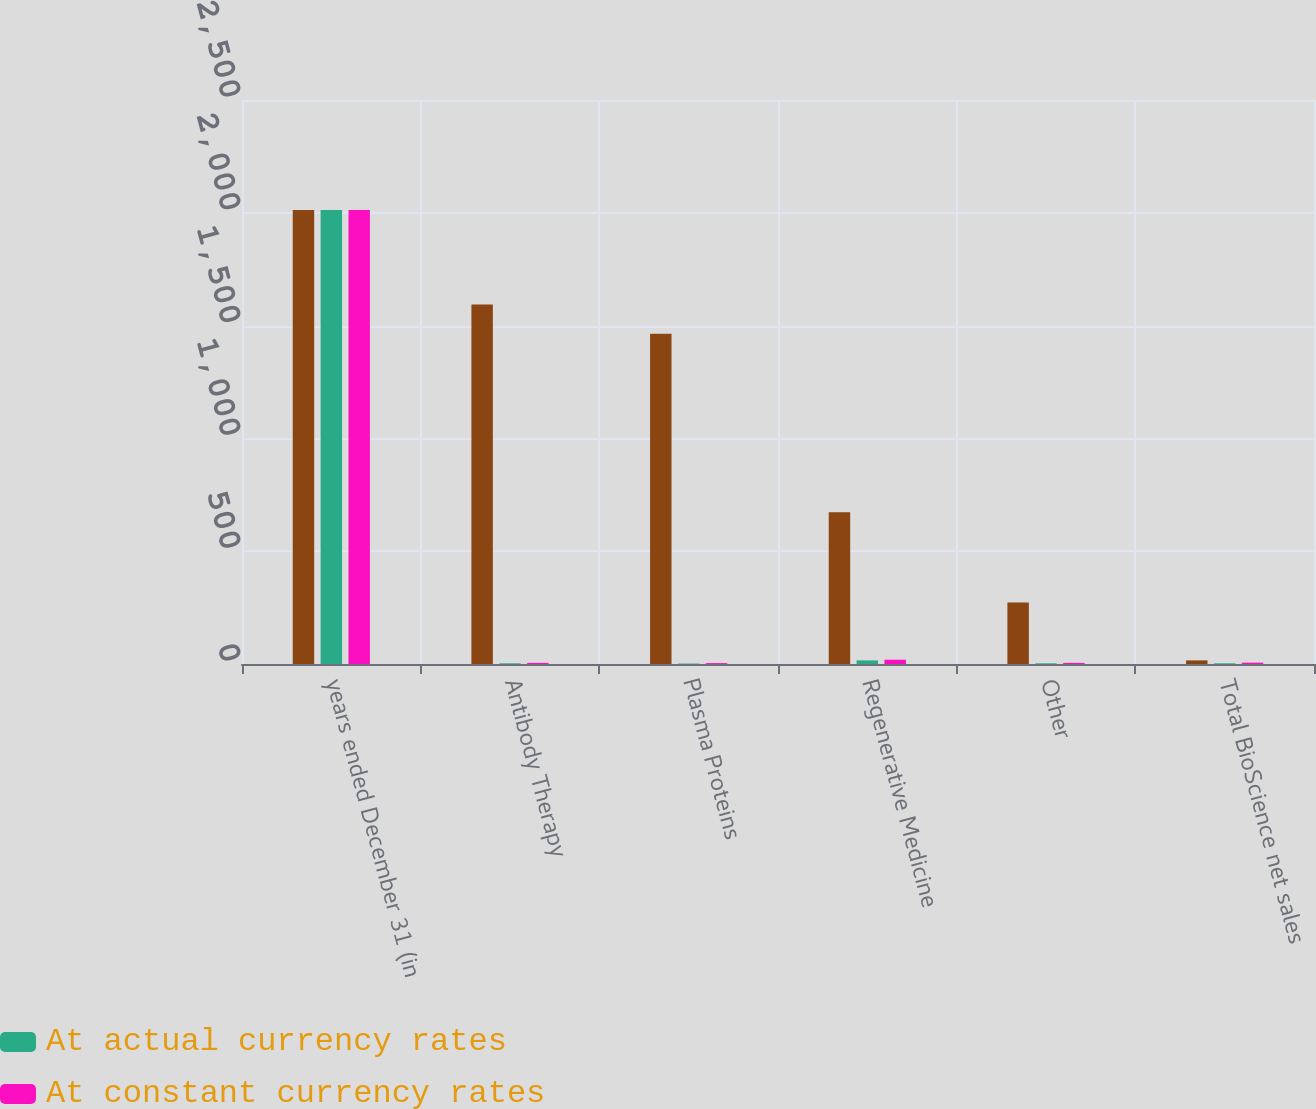Convert chart. <chart><loc_0><loc_0><loc_500><loc_500><stacked_bar_chart><ecel><fcel>years ended December 31 (in<fcel>Antibody Therapy<fcel>Plasma Proteins<fcel>Regenerative Medicine<fcel>Other<fcel>Total BioScience net sales<nl><fcel>nan<fcel>2012<fcel>1593<fcel>1464<fcel>673<fcel>273<fcel>16<nl><fcel>At actual currency rates<fcel>2012<fcel>3<fcel>2<fcel>16<fcel>3<fcel>3<nl><fcel>At constant currency rates<fcel>2012<fcel>5<fcel>4<fcel>19<fcel>5<fcel>6<nl></chart> 